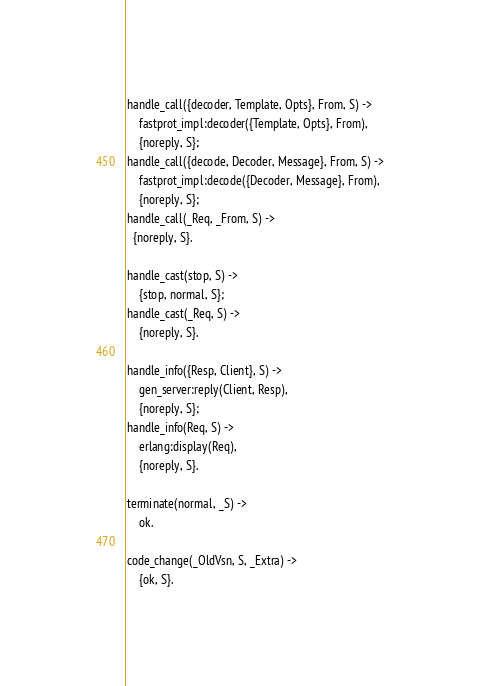Convert code to text. <code><loc_0><loc_0><loc_500><loc_500><_Erlang_>handle_call({decoder, Template, Opts}, From, S) ->
	fastprot_impl:decoder({Template, Opts}, From),
	{noreply, S};
handle_call({decode, Decoder, Message}, From, S) ->
	fastprot_impl:decode({Decoder, Message}, From),
	{noreply, S};
handle_call(_Req, _From, S) ->
  {noreply, S}.

handle_cast(stop, S) ->
	{stop, normal, S};
handle_cast(_Req, S) ->
	{noreply, S}.

handle_info({Resp, Client}, S) ->
	gen_server:reply(Client, Resp),
	{noreply, S};
handle_info(Req, S) ->
	erlang:display(Req),
	{noreply, S}.

terminate(normal, _S) ->
	ok.

code_change(_OldVsn, S, _Extra) ->
	{ok, S}.

</code> 